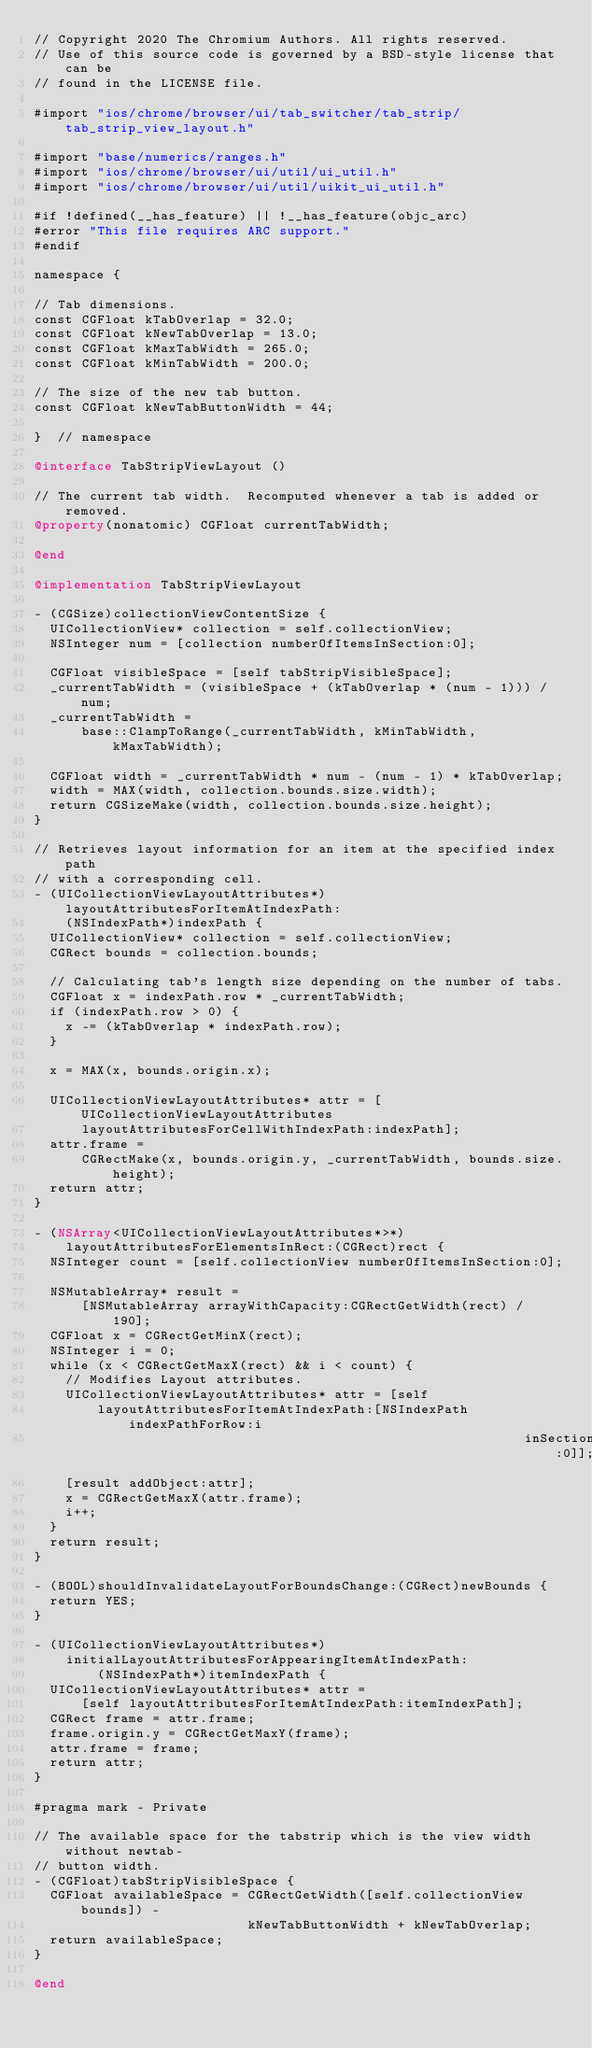Convert code to text. <code><loc_0><loc_0><loc_500><loc_500><_ObjectiveC_>// Copyright 2020 The Chromium Authors. All rights reserved.
// Use of this source code is governed by a BSD-style license that can be
// found in the LICENSE file.

#import "ios/chrome/browser/ui/tab_switcher/tab_strip/tab_strip_view_layout.h"

#import "base/numerics/ranges.h"
#import "ios/chrome/browser/ui/util/ui_util.h"
#import "ios/chrome/browser/ui/util/uikit_ui_util.h"

#if !defined(__has_feature) || !__has_feature(objc_arc)
#error "This file requires ARC support."
#endif

namespace {

// Tab dimensions.
const CGFloat kTabOverlap = 32.0;
const CGFloat kNewTabOverlap = 13.0;
const CGFloat kMaxTabWidth = 265.0;
const CGFloat kMinTabWidth = 200.0;

// The size of the new tab button.
const CGFloat kNewTabButtonWidth = 44;

}  // namespace

@interface TabStripViewLayout ()

// The current tab width.  Recomputed whenever a tab is added or removed.
@property(nonatomic) CGFloat currentTabWidth;

@end

@implementation TabStripViewLayout

- (CGSize)collectionViewContentSize {
  UICollectionView* collection = self.collectionView;
  NSInteger num = [collection numberOfItemsInSection:0];

  CGFloat visibleSpace = [self tabStripVisibleSpace];
  _currentTabWidth = (visibleSpace + (kTabOverlap * (num - 1))) / num;
  _currentTabWidth =
      base::ClampToRange(_currentTabWidth, kMinTabWidth, kMaxTabWidth);

  CGFloat width = _currentTabWidth * num - (num - 1) * kTabOverlap;
  width = MAX(width, collection.bounds.size.width);
  return CGSizeMake(width, collection.bounds.size.height);
}

// Retrieves layout information for an item at the specified index path
// with a corresponding cell.
- (UICollectionViewLayoutAttributes*)layoutAttributesForItemAtIndexPath:
    (NSIndexPath*)indexPath {
  UICollectionView* collection = self.collectionView;
  CGRect bounds = collection.bounds;

  // Calculating tab's length size depending on the number of tabs.
  CGFloat x = indexPath.row * _currentTabWidth;
  if (indexPath.row > 0) {
    x -= (kTabOverlap * indexPath.row);
  }

  x = MAX(x, bounds.origin.x);

  UICollectionViewLayoutAttributes* attr = [UICollectionViewLayoutAttributes
      layoutAttributesForCellWithIndexPath:indexPath];
  attr.frame =
      CGRectMake(x, bounds.origin.y, _currentTabWidth, bounds.size.height);
  return attr;
}

- (NSArray<UICollectionViewLayoutAttributes*>*)
    layoutAttributesForElementsInRect:(CGRect)rect {
  NSInteger count = [self.collectionView numberOfItemsInSection:0];

  NSMutableArray* result =
      [NSMutableArray arrayWithCapacity:CGRectGetWidth(rect) / 190];
  CGFloat x = CGRectGetMinX(rect);
  NSInteger i = 0;
  while (x < CGRectGetMaxX(rect) && i < count) {
    // Modifies Layout attributes.
    UICollectionViewLayoutAttributes* attr = [self
        layoutAttributesForItemAtIndexPath:[NSIndexPath indexPathForRow:i
                                                              inSection:0]];
    [result addObject:attr];
    x = CGRectGetMaxX(attr.frame);
    i++;
  }
  return result;
}

- (BOOL)shouldInvalidateLayoutForBoundsChange:(CGRect)newBounds {
  return YES;
}

- (UICollectionViewLayoutAttributes*)
    initialLayoutAttributesForAppearingItemAtIndexPath:
        (NSIndexPath*)itemIndexPath {
  UICollectionViewLayoutAttributes* attr =
      [self layoutAttributesForItemAtIndexPath:itemIndexPath];
  CGRect frame = attr.frame;
  frame.origin.y = CGRectGetMaxY(frame);
  attr.frame = frame;
  return attr;
}

#pragma mark - Private

// The available space for the tabstrip which is the view width without newtab-
// button width.
- (CGFloat)tabStripVisibleSpace {
  CGFloat availableSpace = CGRectGetWidth([self.collectionView bounds]) -
                           kNewTabButtonWidth + kNewTabOverlap;
  return availableSpace;
}

@end
</code> 